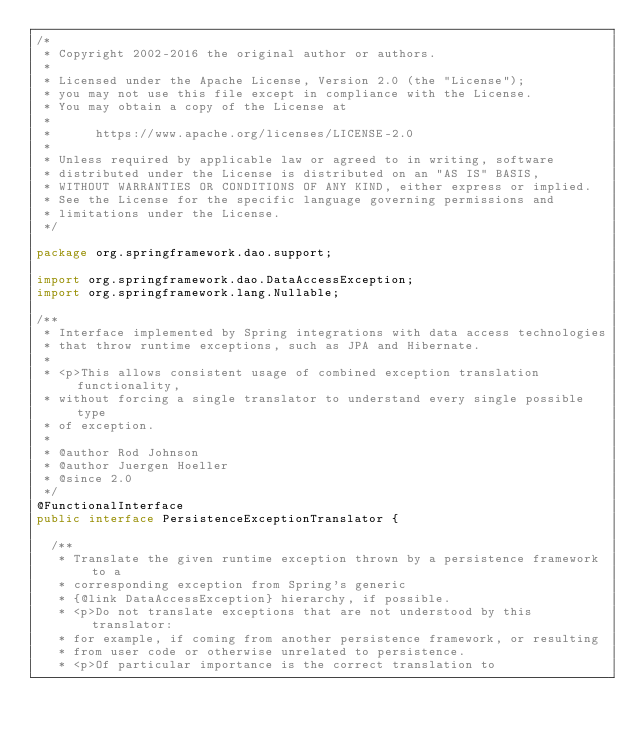Convert code to text. <code><loc_0><loc_0><loc_500><loc_500><_Java_>/*
 * Copyright 2002-2016 the original author or authors.
 *
 * Licensed under the Apache License, Version 2.0 (the "License");
 * you may not use this file except in compliance with the License.
 * You may obtain a copy of the License at
 *
 *      https://www.apache.org/licenses/LICENSE-2.0
 *
 * Unless required by applicable law or agreed to in writing, software
 * distributed under the License is distributed on an "AS IS" BASIS,
 * WITHOUT WARRANTIES OR CONDITIONS OF ANY KIND, either express or implied.
 * See the License for the specific language governing permissions and
 * limitations under the License.
 */

package org.springframework.dao.support;

import org.springframework.dao.DataAccessException;
import org.springframework.lang.Nullable;

/**
 * Interface implemented by Spring integrations with data access technologies
 * that throw runtime exceptions, such as JPA and Hibernate.
 *
 * <p>This allows consistent usage of combined exception translation functionality,
 * without forcing a single translator to understand every single possible type
 * of exception.
 *
 * @author Rod Johnson
 * @author Juergen Hoeller
 * @since 2.0
 */
@FunctionalInterface
public interface PersistenceExceptionTranslator {

	/**
	 * Translate the given runtime exception thrown by a persistence framework to a
	 * corresponding exception from Spring's generic
	 * {@link DataAccessException} hierarchy, if possible.
	 * <p>Do not translate exceptions that are not understood by this translator:
	 * for example, if coming from another persistence framework, or resulting
	 * from user code or otherwise unrelated to persistence.
	 * <p>Of particular importance is the correct translation to</code> 